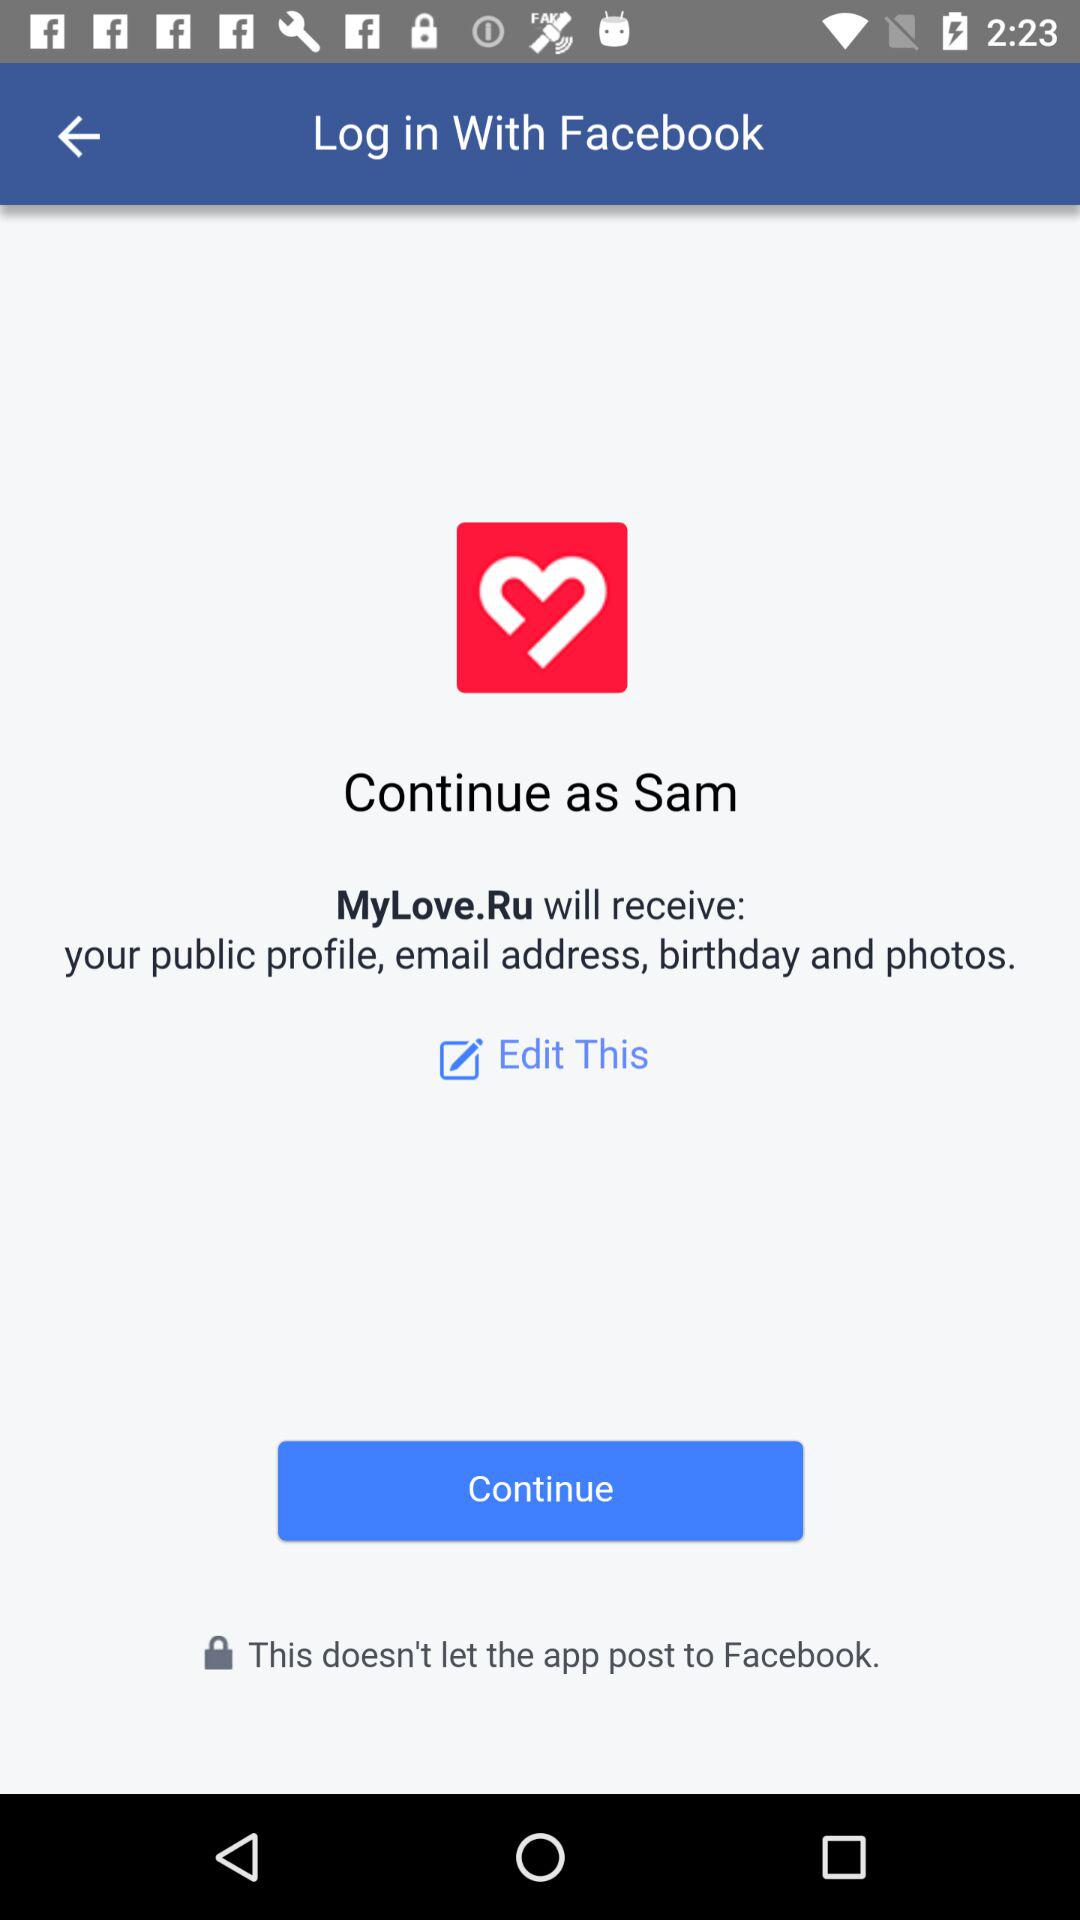What information can we edit? You can edit your public profile, email address, birthday, and photos. 